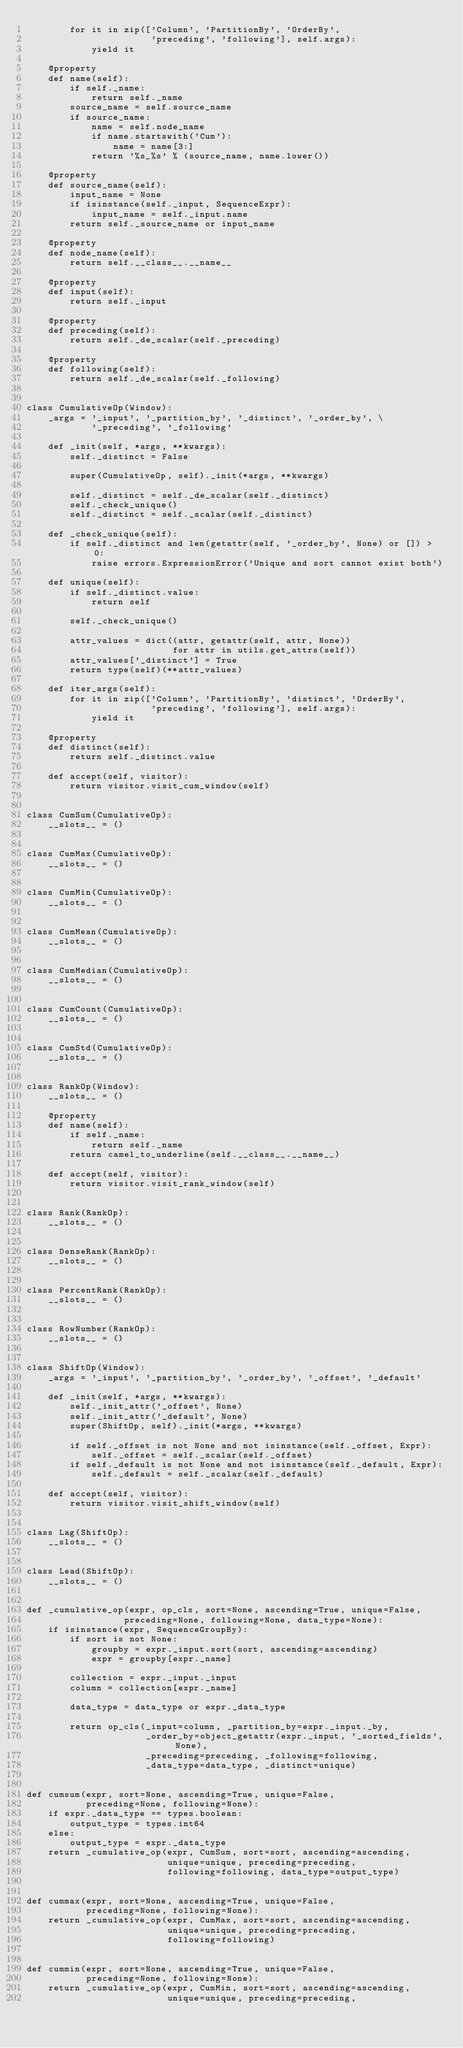<code> <loc_0><loc_0><loc_500><loc_500><_Python_>        for it in zip(['Column', 'PartitionBy', 'OrderBy',
                       'preceding', 'following'], self.args):
            yield it

    @property
    def name(self):
        if self._name:
            return self._name
        source_name = self.source_name
        if source_name:
            name = self.node_name
            if name.startswith('Cum'):
                name = name[3:]
            return '%s_%s' % (source_name, name.lower())

    @property
    def source_name(self):
        input_name = None
        if isinstance(self._input, SequenceExpr):
            input_name = self._input.name
        return self._source_name or input_name

    @property
    def node_name(self):
        return self.__class__.__name__

    @property
    def input(self):
        return self._input

    @property
    def preceding(self):
        return self._de_scalar(self._preceding)

    @property
    def following(self):
        return self._de_scalar(self._following)


class CumulativeOp(Window):
    _args = '_input', '_partition_by', '_distinct', '_order_by', \
            '_preceding', '_following'

    def _init(self, *args, **kwargs):
        self._distinct = False

        super(CumulativeOp, self)._init(*args, **kwargs)

        self._distinct = self._de_scalar(self._distinct)
        self._check_unique()
        self._distinct = self._scalar(self._distinct)

    def _check_unique(self):
        if self._distinct and len(getattr(self, '_order_by', None) or []) > 0:
            raise errors.ExpressionError('Unique and sort cannot exist both')

    def unique(self):
        if self._distinct.value:
            return self

        self._check_unique()

        attr_values = dict((attr, getattr(self, attr, None))
                           for attr in utils.get_attrs(self))
        attr_values['_distinct'] = True
        return type(self)(**attr_values)

    def iter_args(self):
        for it in zip(['Column', 'PartitionBy', 'distinct', 'OrderBy',
                       'preceding', 'following'], self.args):
            yield it

    @property
    def distinct(self):
        return self._distinct.value

    def accept(self, visitor):
        return visitor.visit_cum_window(self)


class CumSum(CumulativeOp):
    __slots__ = ()


class CumMax(CumulativeOp):
    __slots__ = ()


class CumMin(CumulativeOp):
    __slots__ = ()


class CumMean(CumulativeOp):
    __slots__ = ()


class CumMedian(CumulativeOp):
    __slots__ = ()


class CumCount(CumulativeOp):
    __slots__ = ()


class CumStd(CumulativeOp):
    __slots__ = ()


class RankOp(Window):
    __slots__ = ()

    @property
    def name(self):
        if self._name:
            return self._name
        return camel_to_underline(self.__class__.__name__)

    def accept(self, visitor):
        return visitor.visit_rank_window(self)


class Rank(RankOp):
    __slots__ = ()


class DenseRank(RankOp):
    __slots__ = ()


class PercentRank(RankOp):
    __slots__ = ()


class RowNumber(RankOp):
    __slots__ = ()


class ShiftOp(Window):
    _args = '_input', '_partition_by', '_order_by', '_offset', '_default'

    def _init(self, *args, **kwargs):
        self._init_attr('_offset', None)
        self._init_attr('_default', None)
        super(ShiftOp, self)._init(*args, **kwargs)

        if self._offset is not None and not isinstance(self._offset, Expr):
            self._offset = self._scalar(self._offset)
        if self._default is not None and not isinstance(self._default, Expr):
            self._default = self._scalar(self._default)

    def accept(self, visitor):
        return visitor.visit_shift_window(self)


class Lag(ShiftOp):
    __slots__ = ()


class Lead(ShiftOp):
    __slots__ = ()


def _cumulative_op(expr, op_cls, sort=None, ascending=True, unique=False,
                  preceding=None, following=None, data_type=None):
    if isinstance(expr, SequenceGroupBy):
        if sort is not None:
            groupby = expr._input.sort(sort, ascending=ascending)
            expr = groupby[expr._name]

        collection = expr._input._input
        column = collection[expr._name]

        data_type = data_type or expr._data_type

        return op_cls(_input=column, _partition_by=expr._input._by,
                      _order_by=object_getattr(expr._input, '_sorted_fields', None),
                      _preceding=preceding, _following=following,
                      _data_type=data_type, _distinct=unique)


def cumsum(expr, sort=None, ascending=True, unique=False,
           preceding=None, following=None):
    if expr._data_type == types.boolean:
        output_type = types.int64
    else:
        output_type = expr._data_type
    return _cumulative_op(expr, CumSum, sort=sort, ascending=ascending,
                          unique=unique, preceding=preceding,
                          following=following, data_type=output_type)


def cummax(expr, sort=None, ascending=True, unique=False,
           preceding=None, following=None):
    return _cumulative_op(expr, CumMax, sort=sort, ascending=ascending,
                          unique=unique, preceding=preceding,
                          following=following)


def cummin(expr, sort=None, ascending=True, unique=False,
           preceding=None, following=None):
    return _cumulative_op(expr, CumMin, sort=sort, ascending=ascending,
                          unique=unique, preceding=preceding,</code> 